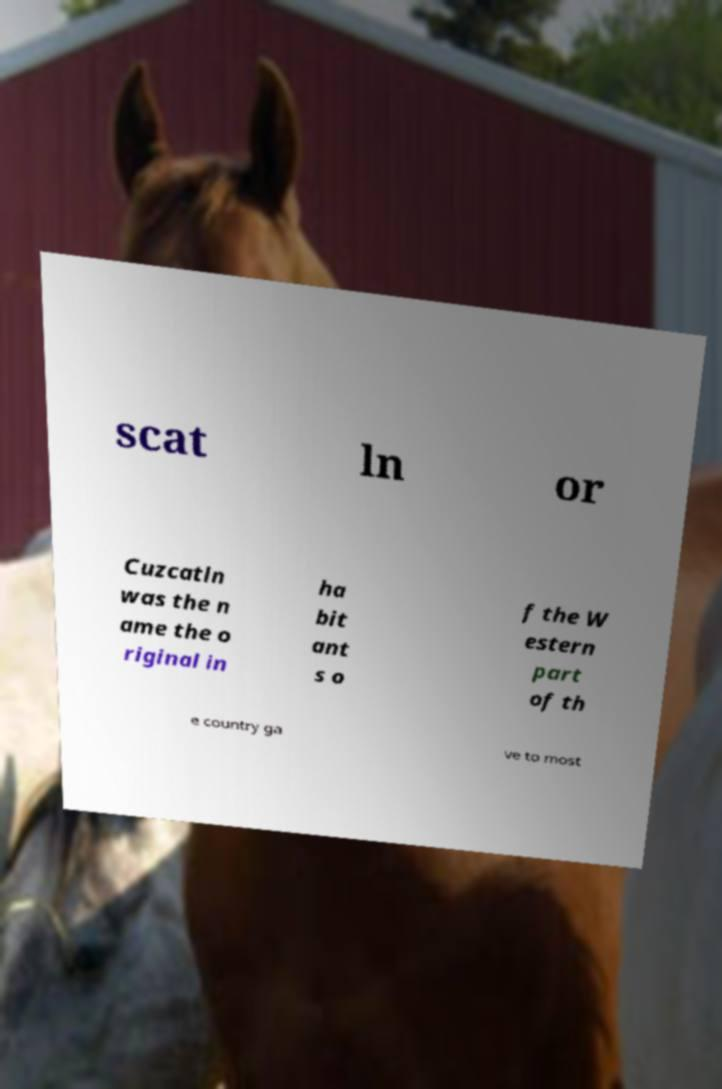Could you assist in decoding the text presented in this image and type it out clearly? scat ln or Cuzcatln was the n ame the o riginal in ha bit ant s o f the W estern part of th e country ga ve to most 